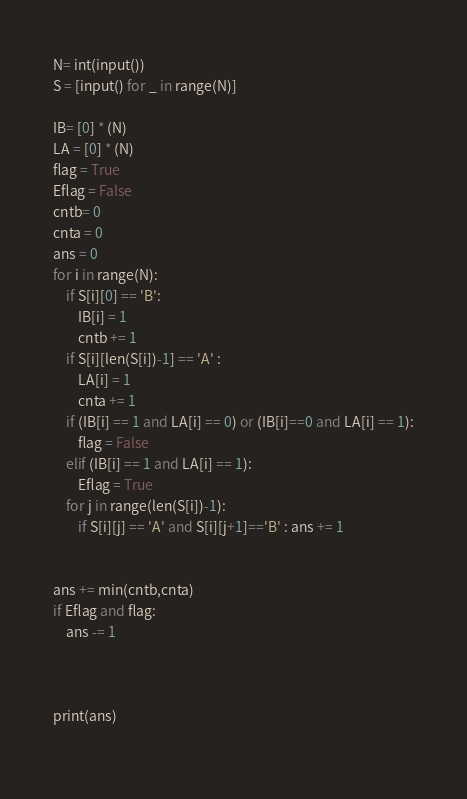<code> <loc_0><loc_0><loc_500><loc_500><_Python_>N= int(input())
S = [input() for _ in range(N)]

IB= [0] * (N)
LA = [0] * (N)
flag = True
Eflag = False
cntb= 0
cnta = 0
ans = 0
for i in range(N):
    if S[i][0] == 'B':
        IB[i] = 1
        cntb += 1
    if S[i][len(S[i])-1] == 'A' :
        LA[i] = 1
        cnta += 1
    if (IB[i] == 1 and LA[i] == 0) or (IB[i]==0 and LA[i] == 1):
        flag = False
    elif (IB[i] == 1 and LA[i] == 1):
        Eflag = True
    for j in range(len(S[i])-1):
        if S[i][j] == 'A' and S[i][j+1]=='B' : ans += 1
        
        
ans += min(cntb,cnta)
if Eflag and flag:    
    ans -= 1



print(ans)
    
</code> 